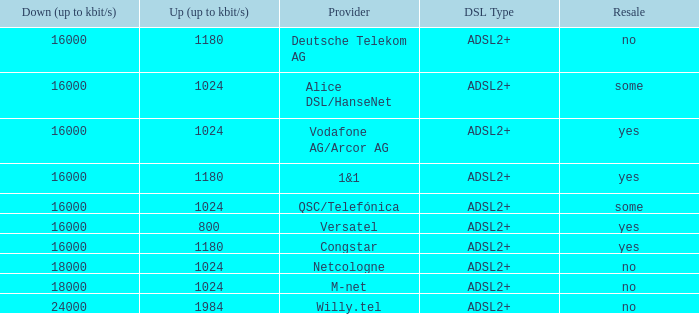What is the resale category for the provider NetCologne? No. 